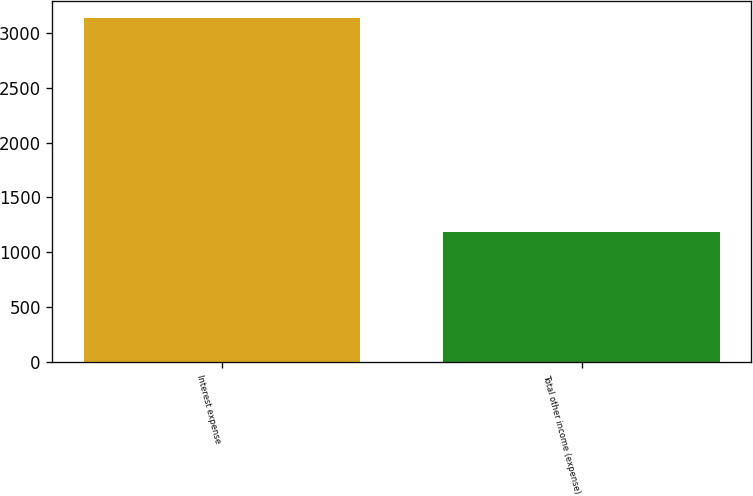Convert chart. <chart><loc_0><loc_0><loc_500><loc_500><bar_chart><fcel>Interest expense<fcel>Total other income (expense)<nl><fcel>3136<fcel>1184<nl></chart> 